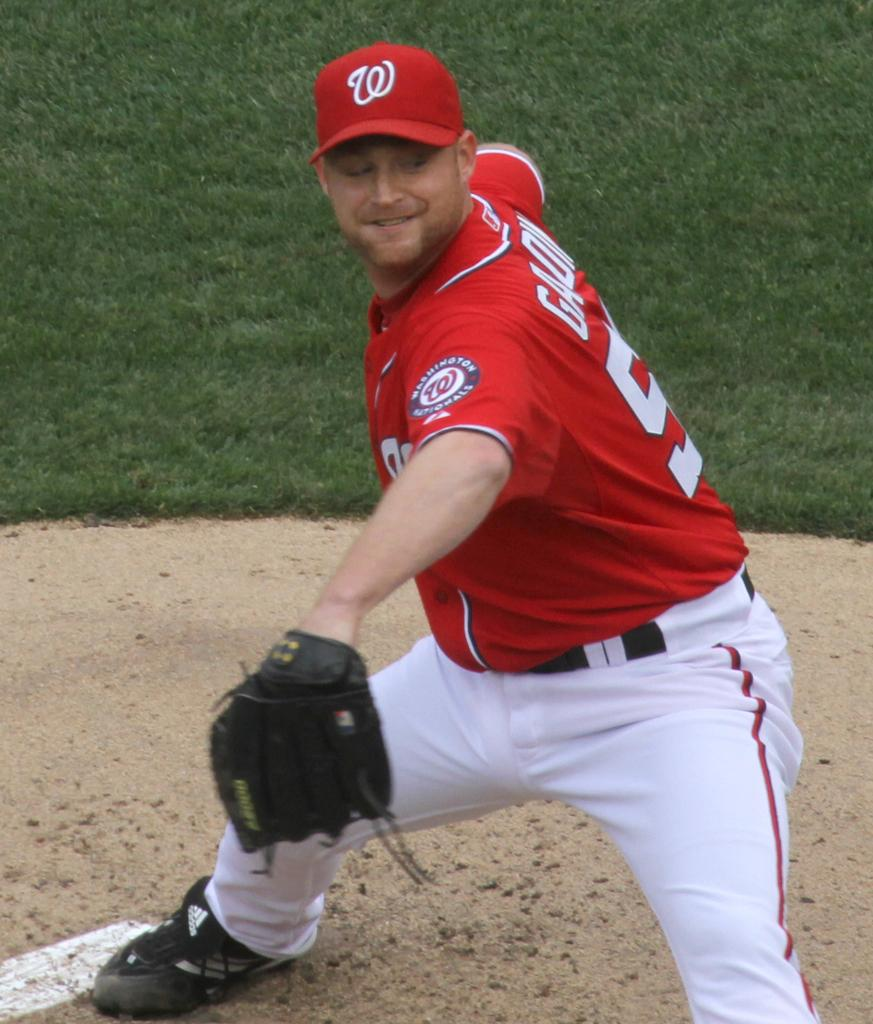<image>
Share a concise interpretation of the image provided. a player that had the letter W on his hat 